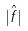<formula> <loc_0><loc_0><loc_500><loc_500>| \hat { f } |</formula> 